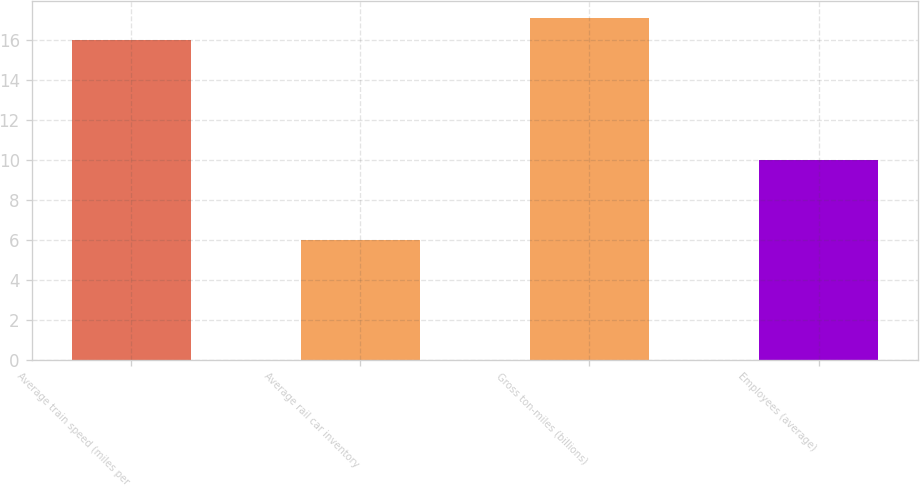Convert chart. <chart><loc_0><loc_0><loc_500><loc_500><bar_chart><fcel>Average train speed (miles per<fcel>Average rail car inventory<fcel>Gross ton-miles (billions)<fcel>Employees (average)<nl><fcel>16<fcel>6<fcel>17.1<fcel>10<nl></chart> 